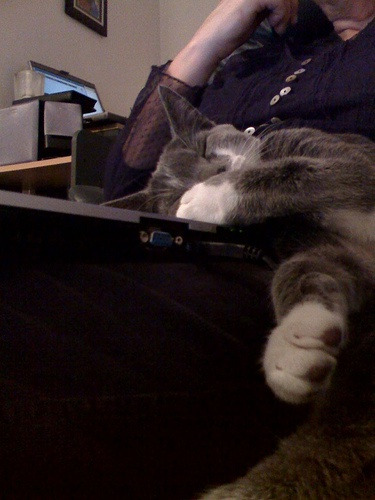Describe the objects in this image and their specific colors. I can see cat in gray and black tones, people in gray, black, maroon, and lightpink tones, laptop in gray and black tones, and laptop in gray, black, and darkgray tones in this image. 